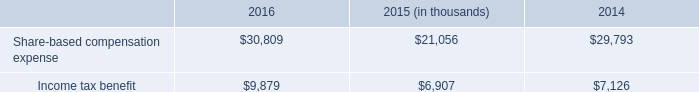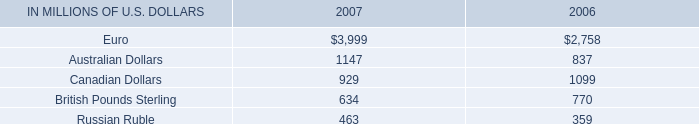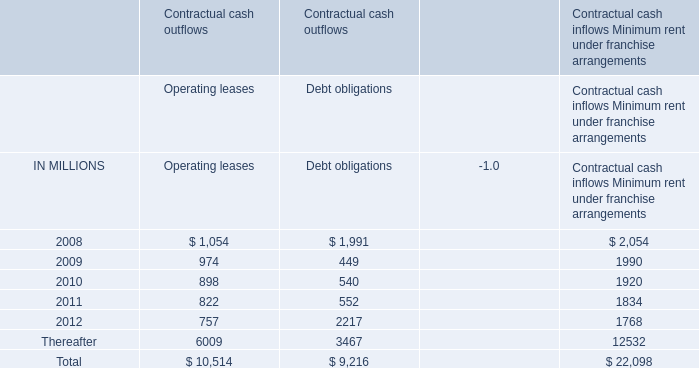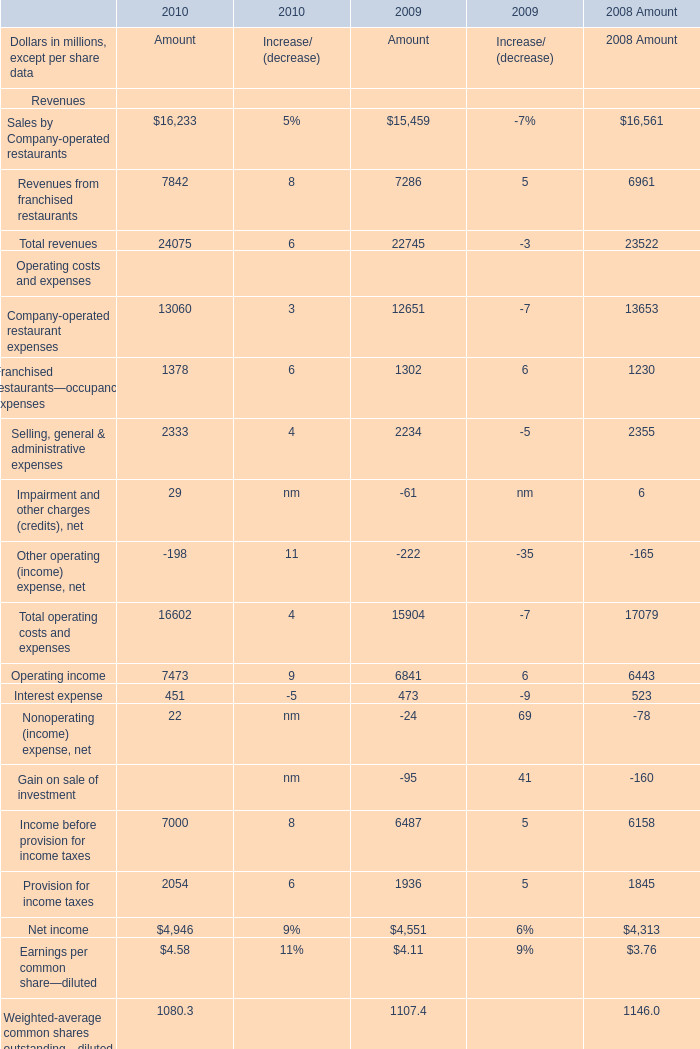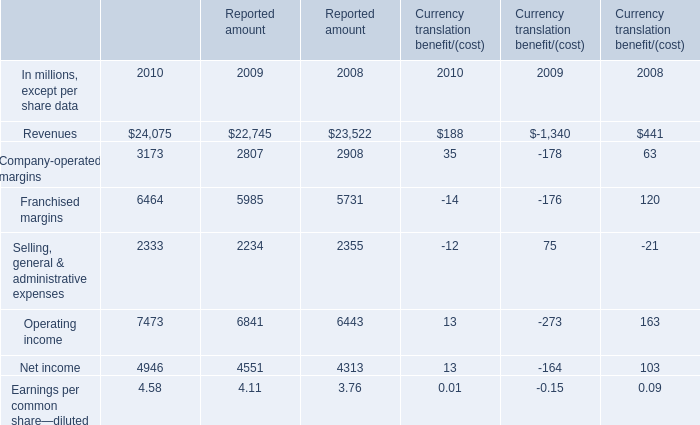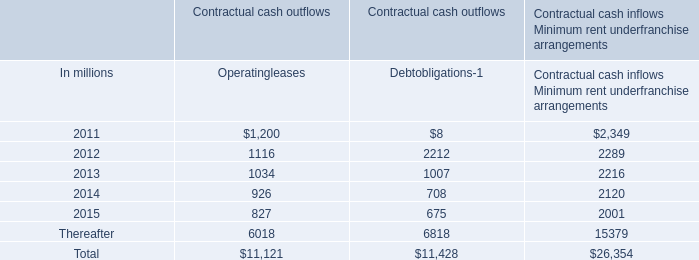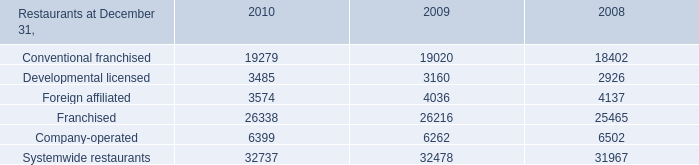What is the sum of Franchised margins, Selling, general & administrative expenses and Operating income in 2009? (in million) 
Computations: (((((5985 + 2234) + 6841) - 176) + 75) - 273)
Answer: 14686.0. 